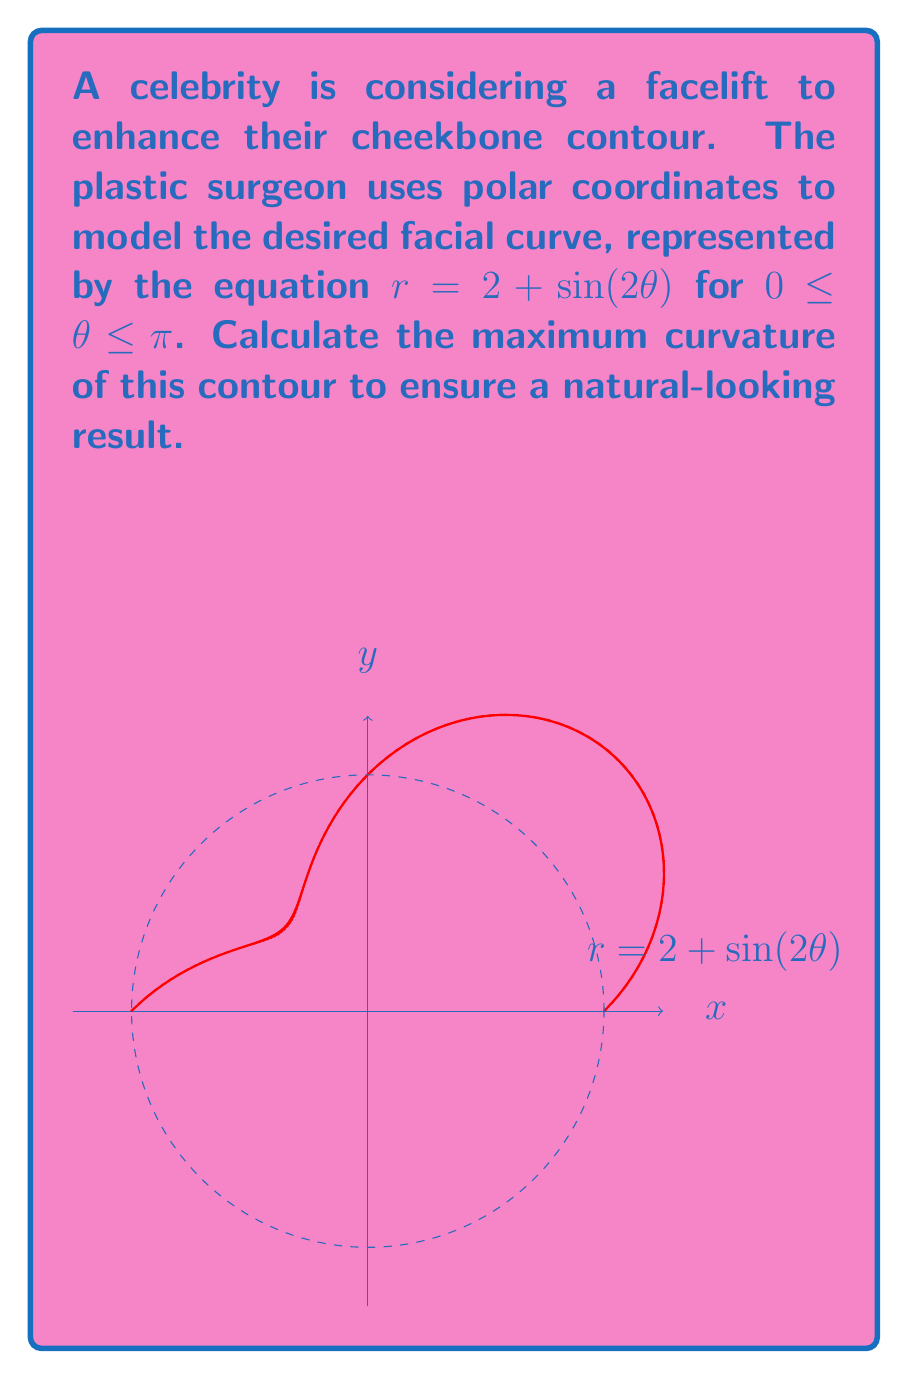Show me your answer to this math problem. To find the maximum curvature, we'll follow these steps:

1) The curvature $\kappa$ in polar coordinates is given by:

   $$\kappa = \frac{|r^2 + 2(r')^2 - rr''|}{(r^2 + (r')^2)^{3/2}}$$

2) We need to calculate $r$, $r'$, and $r''$:
   $r = 2 + \sin(2\theta)$
   $r' = 2\cos(2\theta)$
   $r'' = -4\sin(2\theta)$

3) Substitute these into the curvature formula:

   $$\kappa = \frac{|(2 + \sin(2\theta))^2 + 2(2\cos(2\theta))^2 - (2 + \sin(2\theta))(-4\sin(2\theta))|}{((2 + \sin(2\theta))^2 + (2\cos(2\theta))^2)^{3/2}}$$

4) Simplify:

   $$\kappa = \frac{|4 + 4\sin(2\theta) + \sin^2(2\theta) + 8\cos^2(2\theta) + 8\sin(2\theta) + 4\sin^2(2\theta)|}{(4 + 4\sin(2\theta) + \sin^2(2\theta) + 4\cos^2(2\theta))^{3/2}}$$

5) The maximum curvature will occur when the numerator is at its maximum and the denominator is at its minimum. This happens when $\sin(2\theta) = 1$ and $\cos(2\theta) = 0$.

6) Substituting these values:

   $$\kappa_{max} = \frac{|4 + 4 + 1 + 0 + 8 + 4|}{(4 + 4 + 1 + 0)^{3/2}} = \frac{21}{9^{3/2}} = \frac{7}{9\sqrt{3}}$$
Answer: $\frac{7}{9\sqrt{3}}$ 